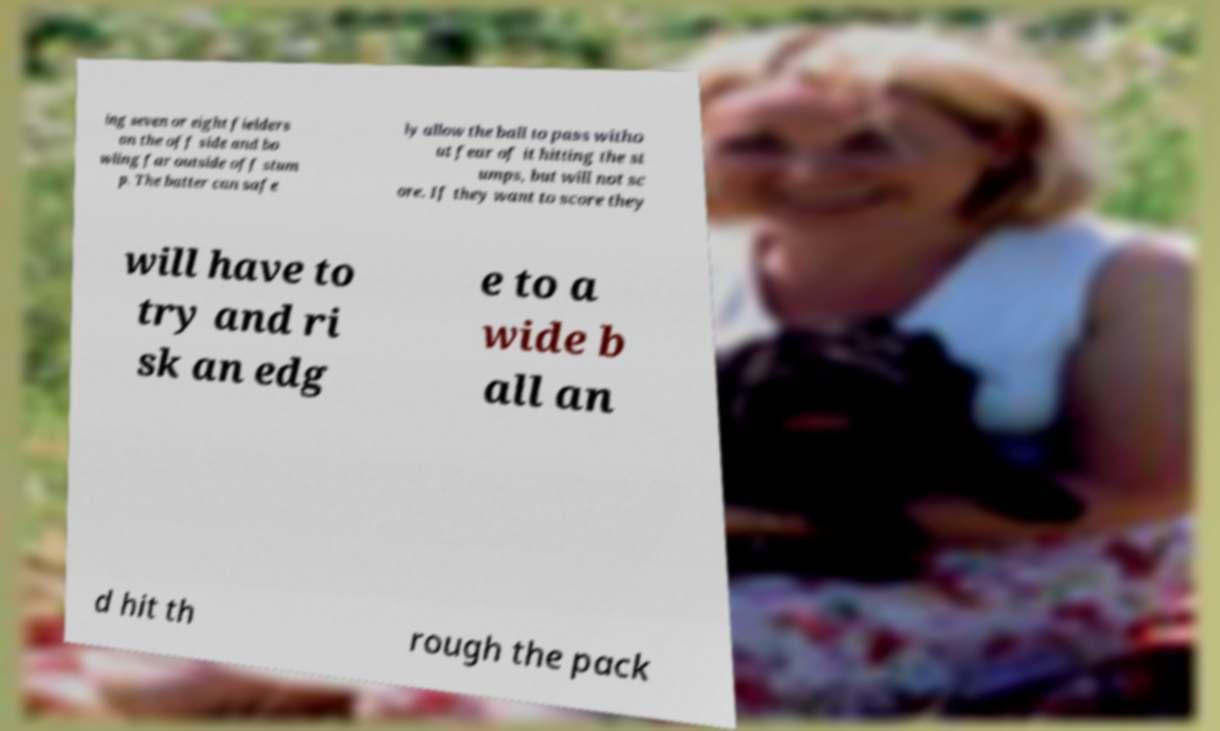What messages or text are displayed in this image? I need them in a readable, typed format. ing seven or eight fielders on the off side and bo wling far outside off stum p. The batter can safe ly allow the ball to pass witho ut fear of it hitting the st umps, but will not sc ore. If they want to score they will have to try and ri sk an edg e to a wide b all an d hit th rough the pack 